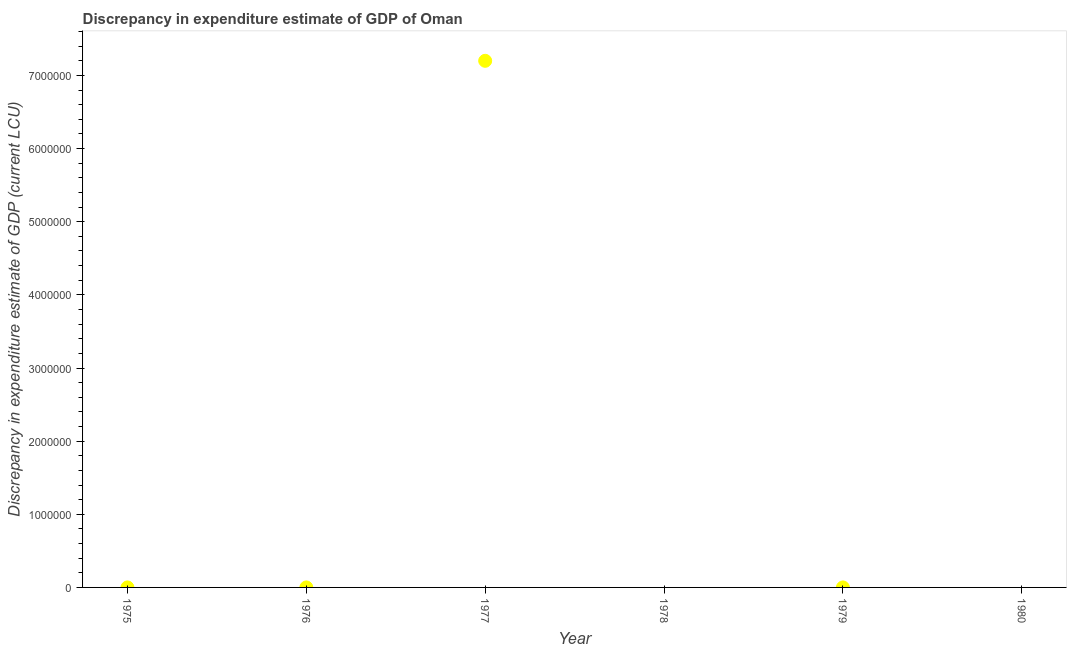Across all years, what is the maximum discrepancy in expenditure estimate of gdp?
Offer a terse response. 7.20e+06. Across all years, what is the minimum discrepancy in expenditure estimate of gdp?
Your response must be concise. 0. What is the sum of the discrepancy in expenditure estimate of gdp?
Your response must be concise. 7.20e+06. What is the difference between the discrepancy in expenditure estimate of gdp in 1975 and 1977?
Provide a short and direct response. -7.20e+06. What is the average discrepancy in expenditure estimate of gdp per year?
Keep it short and to the point. 1.20e+06. What is the median discrepancy in expenditure estimate of gdp?
Keep it short and to the point. 150. What is the ratio of the discrepancy in expenditure estimate of gdp in 1976 to that in 1977?
Provide a succinct answer. 1.3888503084636422e-5. What is the difference between the highest and the second highest discrepancy in expenditure estimate of gdp?
Your answer should be compact. 7.20e+06. What is the difference between the highest and the lowest discrepancy in expenditure estimate of gdp?
Your answer should be very brief. 7.20e+06. In how many years, is the discrepancy in expenditure estimate of gdp greater than the average discrepancy in expenditure estimate of gdp taken over all years?
Provide a succinct answer. 1. How many years are there in the graph?
Keep it short and to the point. 6. What is the difference between two consecutive major ticks on the Y-axis?
Make the answer very short. 1.00e+06. What is the title of the graph?
Make the answer very short. Discrepancy in expenditure estimate of GDP of Oman. What is the label or title of the Y-axis?
Ensure brevity in your answer.  Discrepancy in expenditure estimate of GDP (current LCU). What is the Discrepancy in expenditure estimate of GDP (current LCU) in 1975?
Your answer should be compact. 200. What is the Discrepancy in expenditure estimate of GDP (current LCU) in 1976?
Keep it short and to the point. 100. What is the Discrepancy in expenditure estimate of GDP (current LCU) in 1977?
Offer a terse response. 7.20e+06. What is the Discrepancy in expenditure estimate of GDP (current LCU) in 1979?
Ensure brevity in your answer.  200. What is the difference between the Discrepancy in expenditure estimate of GDP (current LCU) in 1975 and 1976?
Offer a terse response. 100. What is the difference between the Discrepancy in expenditure estimate of GDP (current LCU) in 1975 and 1977?
Keep it short and to the point. -7.20e+06. What is the difference between the Discrepancy in expenditure estimate of GDP (current LCU) in 1976 and 1977?
Your answer should be compact. -7.20e+06. What is the difference between the Discrepancy in expenditure estimate of GDP (current LCU) in 1976 and 1979?
Offer a very short reply. -100. What is the difference between the Discrepancy in expenditure estimate of GDP (current LCU) in 1977 and 1979?
Offer a terse response. 7.20e+06. What is the ratio of the Discrepancy in expenditure estimate of GDP (current LCU) in 1975 to that in 1976?
Keep it short and to the point. 2. What is the ratio of the Discrepancy in expenditure estimate of GDP (current LCU) in 1975 to that in 1979?
Provide a succinct answer. 1. What is the ratio of the Discrepancy in expenditure estimate of GDP (current LCU) in 1976 to that in 1977?
Provide a short and direct response. 0. What is the ratio of the Discrepancy in expenditure estimate of GDP (current LCU) in 1977 to that in 1979?
Your response must be concise. 3.60e+04. 